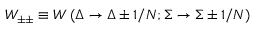Convert formula to latex. <formula><loc_0><loc_0><loc_500><loc_500>W _ { \pm \pm } \equiv W \left ( \Delta \to \Delta \pm 1 / N ; \Sigma \to \Sigma \pm 1 / N \right )</formula> 